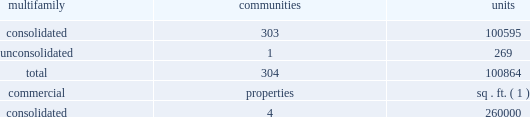2022 level and volatility of interest or capitalization rates or capital market conditions ; 2022 loss of hedge accounting treatment for interest rate swaps ; 2022 the continuation of the good credit of our interest rate swap providers ; 2022 price volatility , dislocations and liquidity disruptions in the financial markets and the resulting impact on financing ; 2022 the effect of any rating agency actions on the cost and availability of new debt financing ; 2022 significant decline in market value of real estate serving as collateral for mortgage obligations ; 2022 significant change in the mortgage financing market that would cause single-family housing , either as an owned or rental product , to become a more significant competitive product ; 2022 our ability to continue to satisfy complex rules in order to maintain our status as a reit for federal income tax purposes , the ability of the operating partnership to satisfy the rules to maintain its status as a partnership for federal income tax purposes , the ability of our taxable reit subsidiaries to maintain their status as such for federal income tax purposes , and our ability and the ability of our subsidiaries to operate effectively within the limitations imposed by these rules ; 2022 inability to attract and retain qualified personnel ; 2022 cyber liability or potential liability for breaches of our privacy or information security systems ; 2022 potential liability for environmental contamination ; 2022 adverse legislative or regulatory tax changes ; 2022 legal proceedings relating to various issues , which , among other things , could result in a class action lawsuit ; 2022 compliance costs associated with laws requiring access for disabled persons ; and 2022 other risks identified in this annual report on form 10-k including under the caption "item 1a .
Risk factors" and , from time to time , in other reports we file with the securities and exchange commission , or the sec , or in other documents that we publicly disseminate .
New factors may also emerge from time to time that could have a material adverse effect on our business .
Except as required by law , we undertake no obligation to publicly update or revise forward-looking statements contained in this annual report on form 10-k to reflect events , circumstances or changes in expectations after the date on which this annual report on form 10-k is filed .
Item 1 .
Business .
Overview maa is a multifamily focused , self-administered and self-managed real estate investment trust , or reit .
We own , operate , acquire and selectively develop apartment communities located in the southeast , southwest and mid-atlantic regions of the united states .
As of december 31 , 2018 , we maintained full or partial ownership of apartment communities and commercial properties across 17 states and the district of columbia , summarized as follows: .
( 1 ) excludes commercial space located at our multifamily apartment communities , which totals approximately 615000 square feet of gross leasable space .
Our business is conducted principally through the operating partnership .
Maa is the sole general partner of the operating partnership , holding 113844267 op units , comprising a 96.5% ( 96.5 % ) partnership interest in the operating partnership as of december 31 , 2018 .
Maa and maalp were formed in tennessee in 1993 .
As of december 31 , 2018 , we had 2508 full- time employees and 44 part-time employees. .
What is the percentage of consolidated communities among the total communities? 
Rationale: it is the number of consolidated communities divided by the total number of communities , then turned into a percentage .
Computations: (303 / 304)
Answer: 0.99671. 